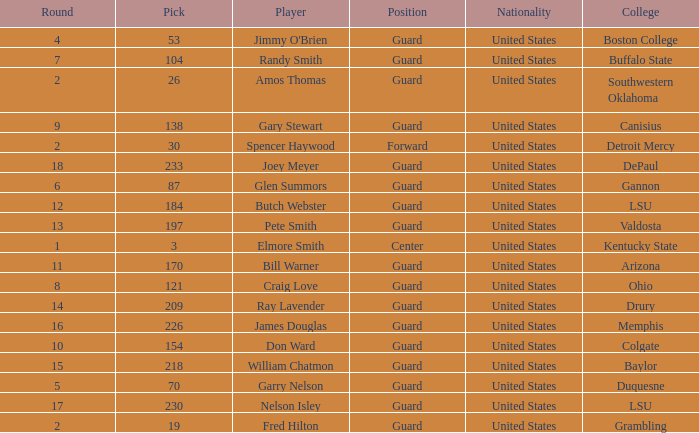WHAT IS THE NATIONALITY FOR SOUTHWESTERN OKLAHOMA? United States. 